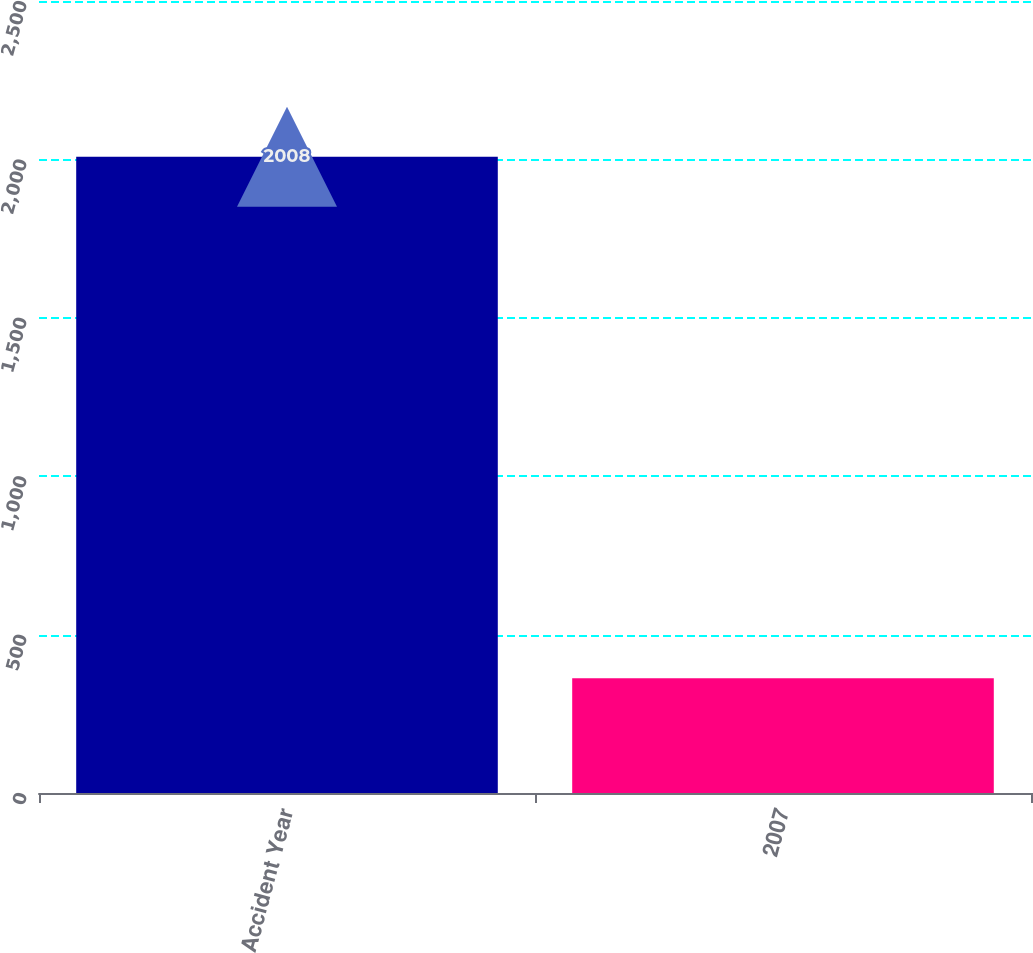Convert chart. <chart><loc_0><loc_0><loc_500><loc_500><bar_chart><fcel>Accident Year<fcel>2007<nl><fcel>2008<fcel>362<nl></chart> 